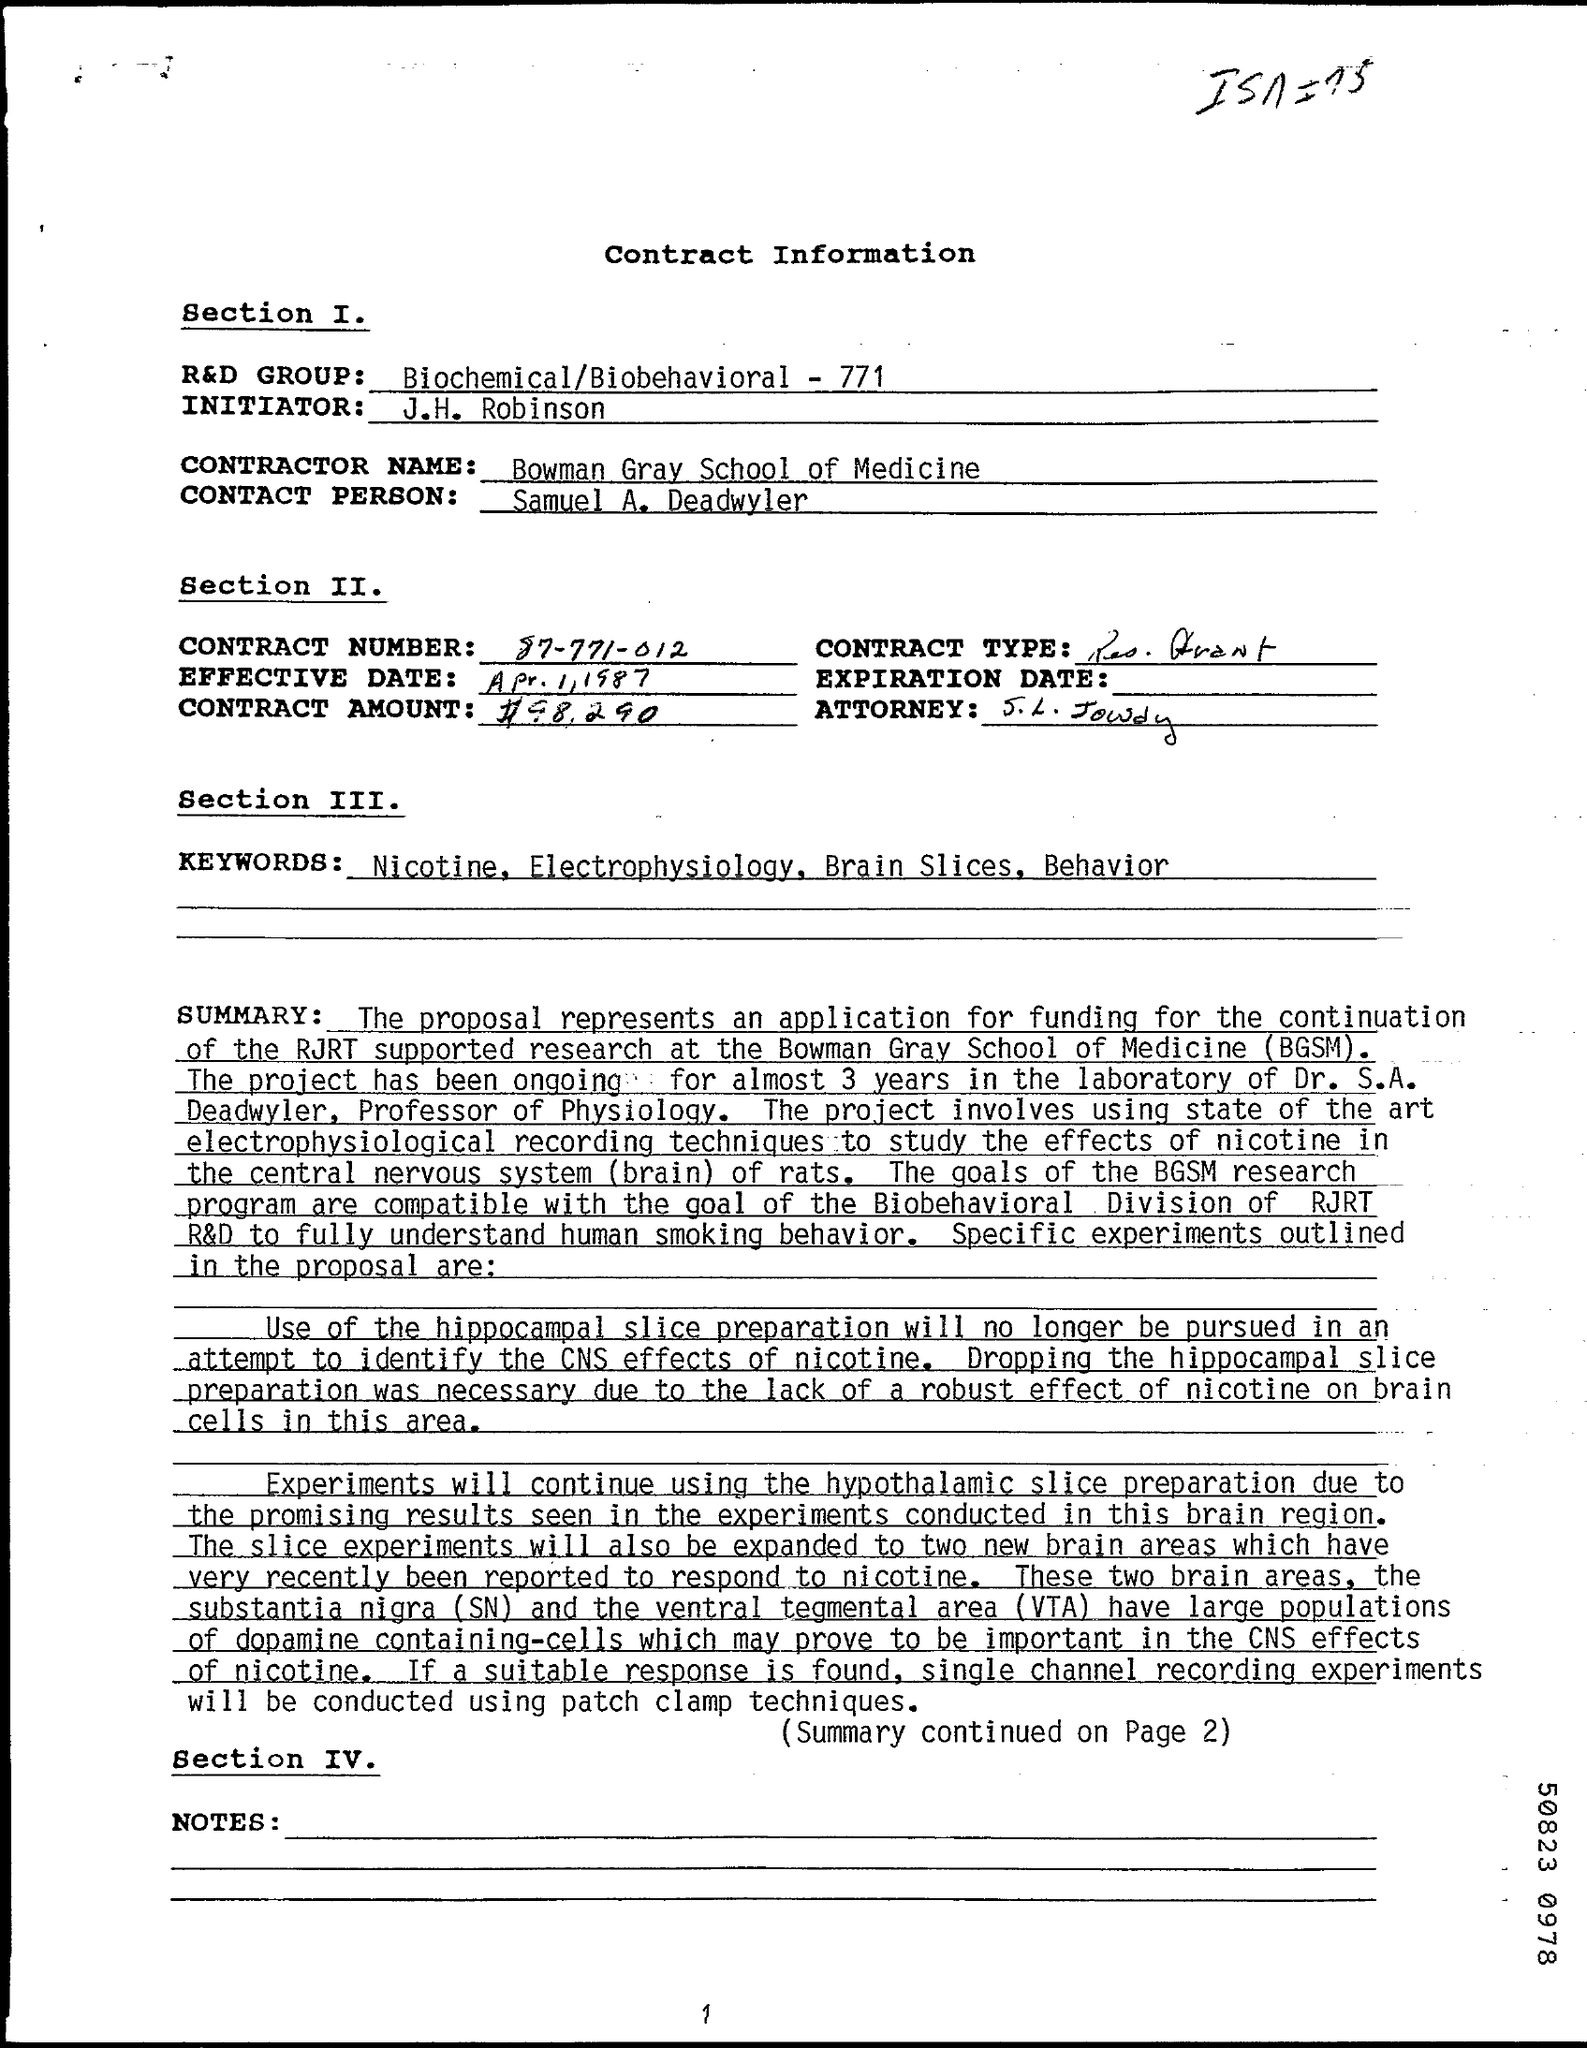Draw attention to some important aspects in this diagram. The Contractor Name is Bowman Gray School of Medicine. The contract number is 87-771-012. The person's name is Samuel A. Deadwyler. The R&D GROUP field contains the information "Biochemical/Biobehavioral - 771. The initiator is J.H. Robinson. 